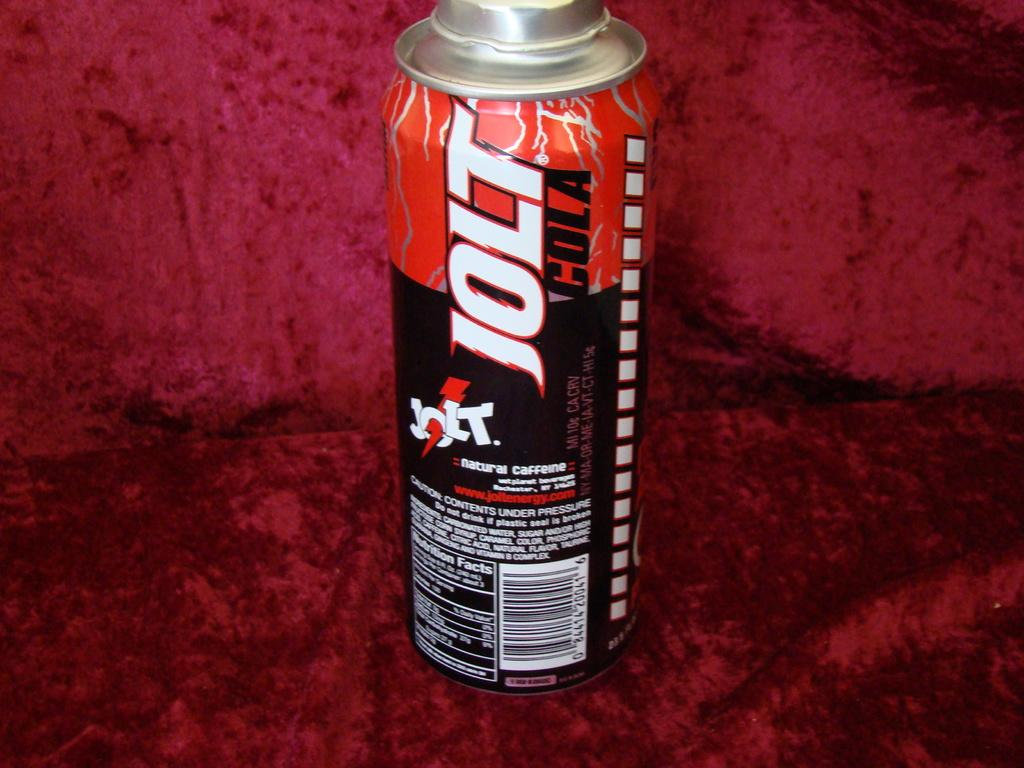<image>
Relay a brief, clear account of the picture shown. a close up of a Jolt Cola red and black can 